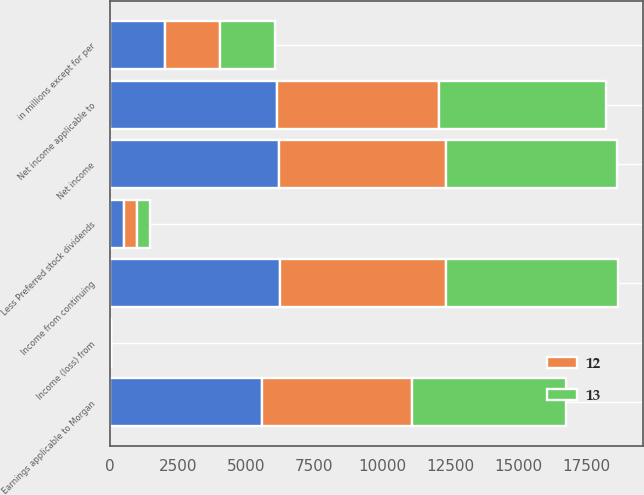Convert chart. <chart><loc_0><loc_0><loc_500><loc_500><stacked_bar_chart><ecel><fcel>in millions except for per<fcel>Income from continuing<fcel>Income (loss) from<fcel>Net income<fcel>Net income applicable to<fcel>Less Preferred stock dividends<fcel>Earnings applicable to Morgan<nl><fcel>nan<fcel>2017<fcel>6235<fcel>19<fcel>6216<fcel>6111<fcel>523<fcel>5588<nl><fcel>12<fcel>2016<fcel>6122<fcel>1<fcel>6123<fcel>5979<fcel>471<fcel>5508<nl><fcel>13<fcel>2015<fcel>6295<fcel>16<fcel>6279<fcel>6127<fcel>456<fcel>5671<nl></chart> 